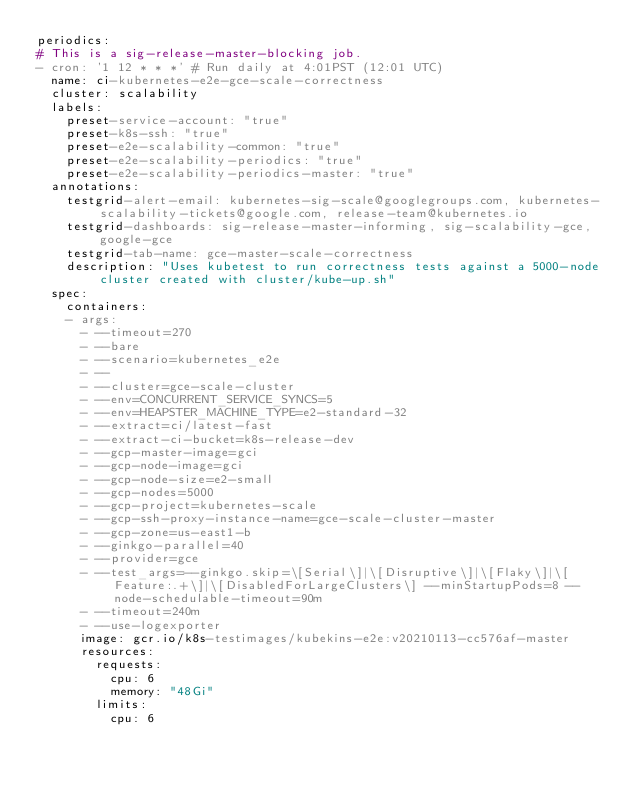<code> <loc_0><loc_0><loc_500><loc_500><_YAML_>periodics:
# This is a sig-release-master-blocking job.
- cron: '1 12 * * *' # Run daily at 4:01PST (12:01 UTC)
  name: ci-kubernetes-e2e-gce-scale-correctness
  cluster: scalability
  labels:
    preset-service-account: "true"
    preset-k8s-ssh: "true"
    preset-e2e-scalability-common: "true"
    preset-e2e-scalability-periodics: "true"
    preset-e2e-scalability-periodics-master: "true"
  annotations:
    testgrid-alert-email: kubernetes-sig-scale@googlegroups.com, kubernetes-scalability-tickets@google.com, release-team@kubernetes.io
    testgrid-dashboards: sig-release-master-informing, sig-scalability-gce, google-gce
    testgrid-tab-name: gce-master-scale-correctness
    description: "Uses kubetest to run correctness tests against a 5000-node cluster created with cluster/kube-up.sh"
  spec:
    containers:
    - args:
      - --timeout=270
      - --bare
      - --scenario=kubernetes_e2e
      - --
      - --cluster=gce-scale-cluster
      - --env=CONCURRENT_SERVICE_SYNCS=5
      - --env=HEAPSTER_MACHINE_TYPE=e2-standard-32
      - --extract=ci/latest-fast
      - --extract-ci-bucket=k8s-release-dev
      - --gcp-master-image=gci
      - --gcp-node-image=gci
      - --gcp-node-size=e2-small
      - --gcp-nodes=5000
      - --gcp-project=kubernetes-scale
      - --gcp-ssh-proxy-instance-name=gce-scale-cluster-master
      - --gcp-zone=us-east1-b
      - --ginkgo-parallel=40
      - --provider=gce
      - --test_args=--ginkgo.skip=\[Serial\]|\[Disruptive\]|\[Flaky\]|\[Feature:.+\]|\[DisabledForLargeClusters\] --minStartupPods=8 --node-schedulable-timeout=90m
      - --timeout=240m
      - --use-logexporter
      image: gcr.io/k8s-testimages/kubekins-e2e:v20210113-cc576af-master
      resources:
        requests:
          cpu: 6
          memory: "48Gi"
        limits:
          cpu: 6</code> 